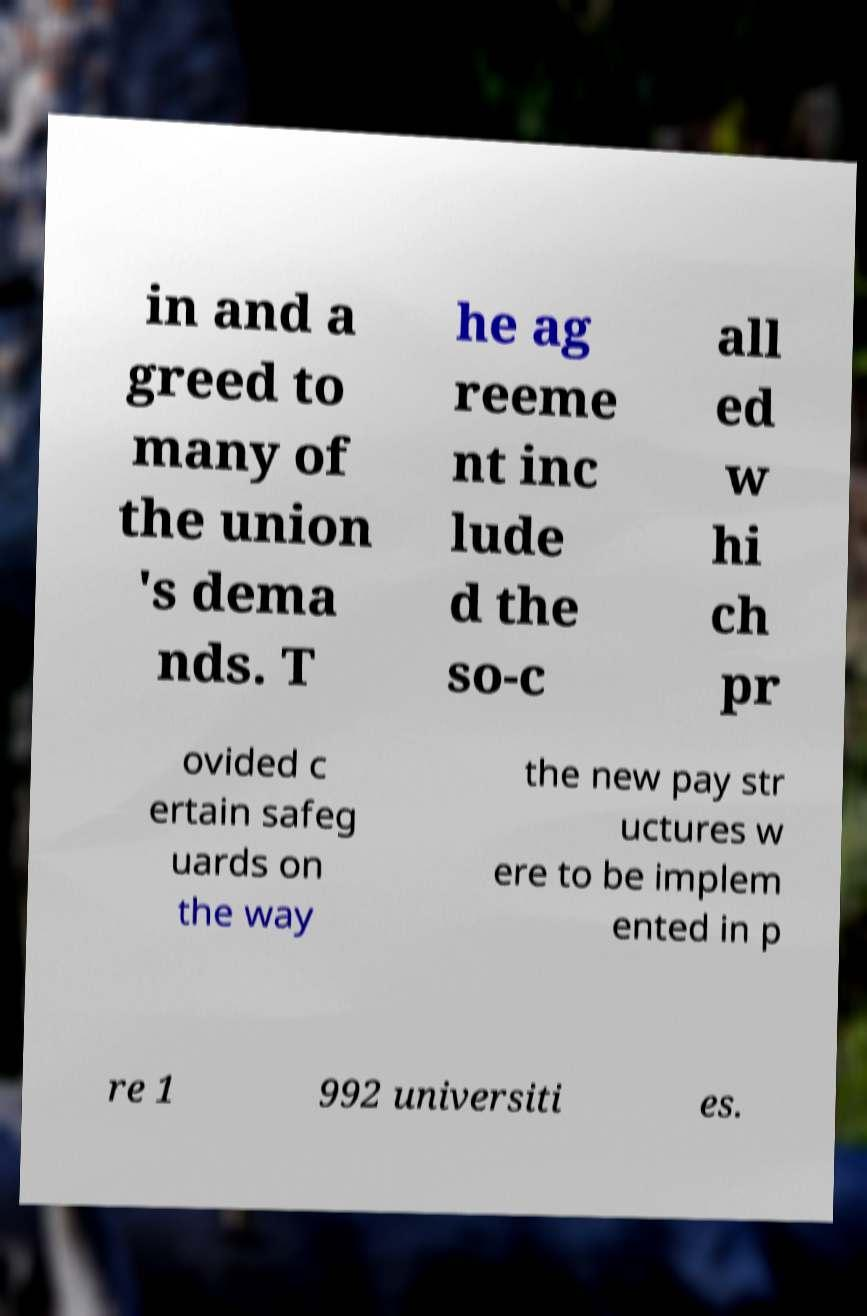Could you extract and type out the text from this image? in and a greed to many of the union 's dema nds. T he ag reeme nt inc lude d the so-c all ed w hi ch pr ovided c ertain safeg uards on the way the new pay str uctures w ere to be implem ented in p re 1 992 universiti es. 